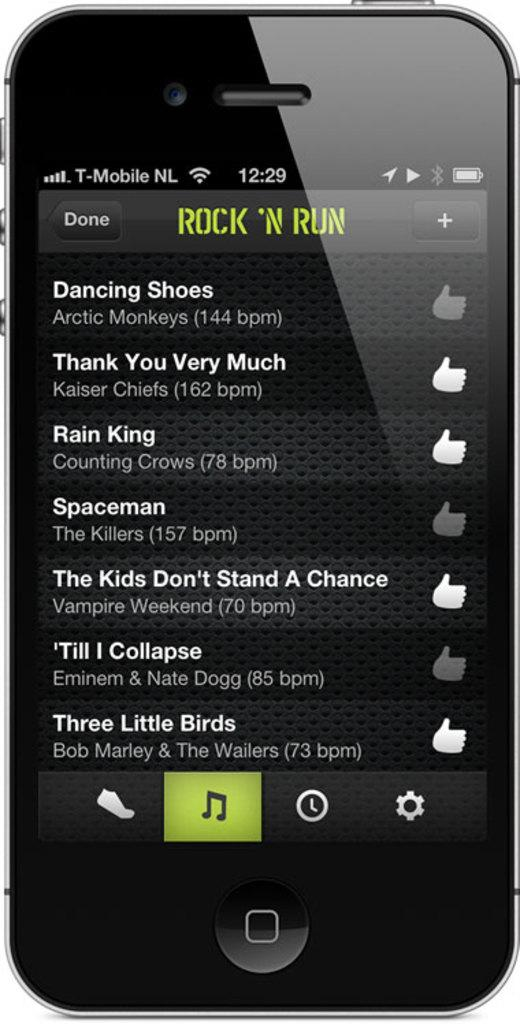<image>
Render a clear and concise summary of the photo. A smart phone screen shows music selections from a playlist called Rock N Run. 